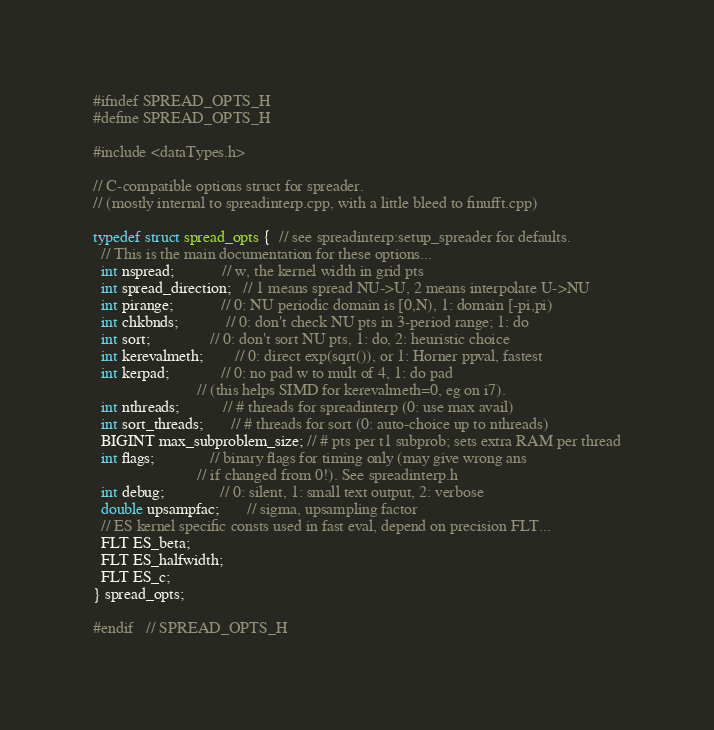<code> <loc_0><loc_0><loc_500><loc_500><_C_>#ifndef SPREAD_OPTS_H
#define SPREAD_OPTS_H

#include <dataTypes.h>

// C-compatible options struct for spreader.
// (mostly internal to spreadinterp.cpp, with a little bleed to finufft.cpp)

typedef struct spread_opts {  // see spreadinterp:setup_spreader for defaults.
  // This is the main documentation for these options...
  int nspread;            // w, the kernel width in grid pts
  int spread_direction;   // 1 means spread NU->U, 2 means interpolate U->NU
  int pirange;            // 0: NU periodic domain is [0,N), 1: domain [-pi,pi)
  int chkbnds;            // 0: don't check NU pts in 3-period range; 1: do
  int sort;               // 0: don't sort NU pts, 1: do, 2: heuristic choice
  int kerevalmeth;        // 0: direct exp(sqrt()), or 1: Horner ppval, fastest
  int kerpad;             // 0: no pad w to mult of 4, 1: do pad
                          // (this helps SIMD for kerevalmeth=0, eg on i7).
  int nthreads;           // # threads for spreadinterp (0: use max avail)
  int sort_threads;       // # threads for sort (0: auto-choice up to nthreads)
  BIGINT max_subproblem_size; // # pts per t1 subprob; sets extra RAM per thread
  int flags;              // binary flags for timing only (may give wrong ans
                          // if changed from 0!). See spreadinterp.h
  int debug;              // 0: silent, 1: small text output, 2: verbose
  double upsampfac;       // sigma, upsampling factor
  // ES kernel specific consts used in fast eval, depend on precision FLT...
  FLT ES_beta;
  FLT ES_halfwidth;
  FLT ES_c;
} spread_opts;

#endif   // SPREAD_OPTS_H
</code> 